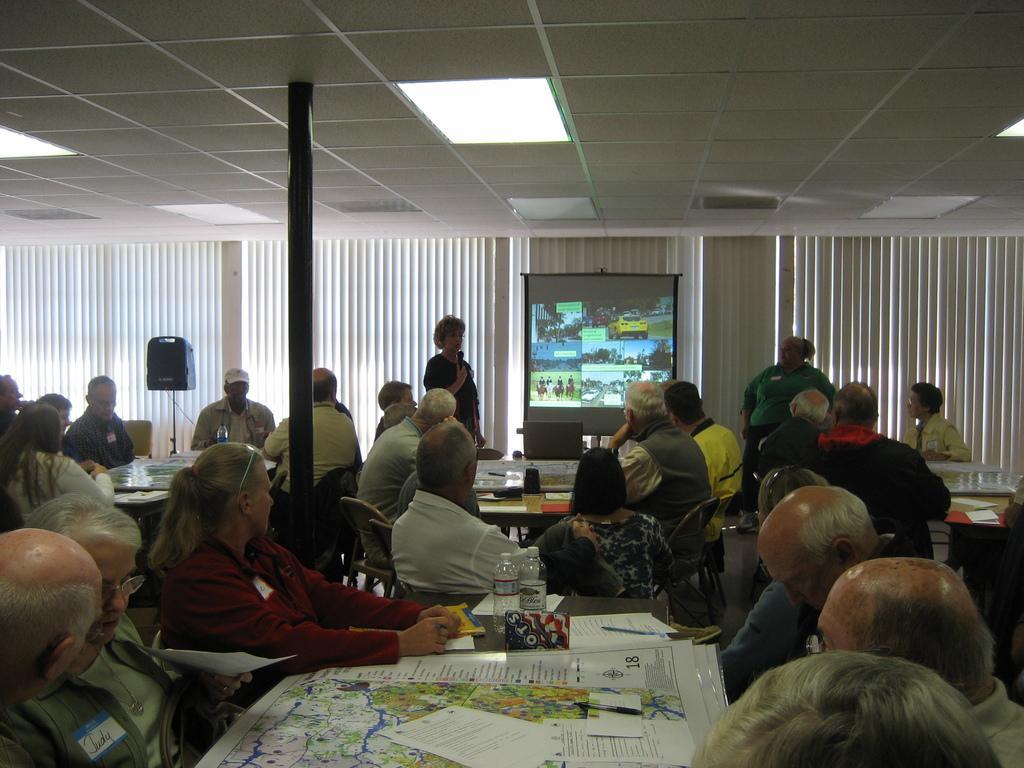Please provide a concise description of this image. Here we can see a group of people sitting in a conference hall and in the center there is a woman standing speaking in the microphone and besides her we can see a projector screen she is probably explaining something and at the left side we can see speaker at the top we can see light 